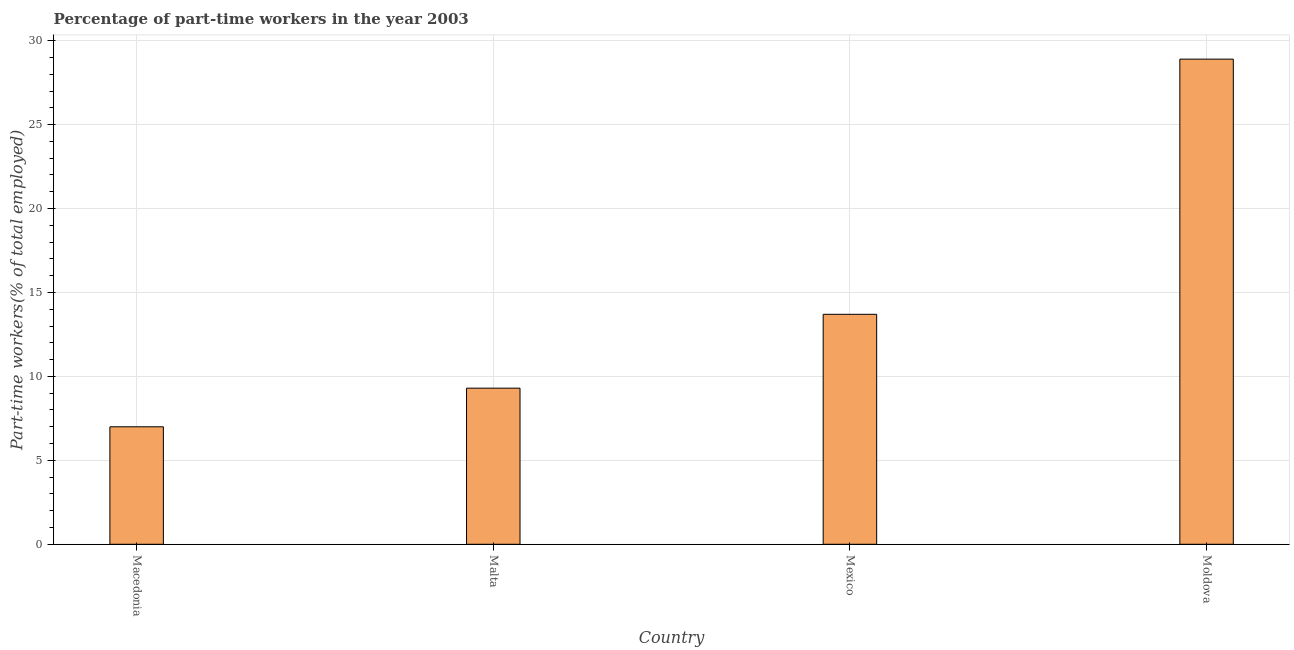Does the graph contain any zero values?
Offer a terse response. No. Does the graph contain grids?
Your answer should be compact. Yes. What is the title of the graph?
Your answer should be compact. Percentage of part-time workers in the year 2003. What is the label or title of the X-axis?
Offer a very short reply. Country. What is the label or title of the Y-axis?
Make the answer very short. Part-time workers(% of total employed). What is the percentage of part-time workers in Mexico?
Provide a short and direct response. 13.7. Across all countries, what is the maximum percentage of part-time workers?
Your response must be concise. 28.9. In which country was the percentage of part-time workers maximum?
Your answer should be compact. Moldova. In which country was the percentage of part-time workers minimum?
Your answer should be compact. Macedonia. What is the sum of the percentage of part-time workers?
Your response must be concise. 58.9. What is the difference between the percentage of part-time workers in Mexico and Moldova?
Provide a succinct answer. -15.2. What is the average percentage of part-time workers per country?
Provide a short and direct response. 14.72. What is the median percentage of part-time workers?
Offer a very short reply. 11.5. In how many countries, is the percentage of part-time workers greater than 26 %?
Give a very brief answer. 1. What is the ratio of the percentage of part-time workers in Malta to that in Moldova?
Your answer should be compact. 0.32. What is the difference between the highest and the second highest percentage of part-time workers?
Give a very brief answer. 15.2. Is the sum of the percentage of part-time workers in Malta and Moldova greater than the maximum percentage of part-time workers across all countries?
Provide a succinct answer. Yes. What is the difference between the highest and the lowest percentage of part-time workers?
Give a very brief answer. 21.9. In how many countries, is the percentage of part-time workers greater than the average percentage of part-time workers taken over all countries?
Provide a succinct answer. 1. How many bars are there?
Offer a very short reply. 4. Are all the bars in the graph horizontal?
Offer a terse response. No. What is the Part-time workers(% of total employed) in Malta?
Ensure brevity in your answer.  9.3. What is the Part-time workers(% of total employed) of Mexico?
Your answer should be very brief. 13.7. What is the Part-time workers(% of total employed) in Moldova?
Offer a terse response. 28.9. What is the difference between the Part-time workers(% of total employed) in Macedonia and Malta?
Your response must be concise. -2.3. What is the difference between the Part-time workers(% of total employed) in Macedonia and Moldova?
Make the answer very short. -21.9. What is the difference between the Part-time workers(% of total employed) in Malta and Moldova?
Make the answer very short. -19.6. What is the difference between the Part-time workers(% of total employed) in Mexico and Moldova?
Your answer should be very brief. -15.2. What is the ratio of the Part-time workers(% of total employed) in Macedonia to that in Malta?
Provide a short and direct response. 0.75. What is the ratio of the Part-time workers(% of total employed) in Macedonia to that in Mexico?
Make the answer very short. 0.51. What is the ratio of the Part-time workers(% of total employed) in Macedonia to that in Moldova?
Your answer should be very brief. 0.24. What is the ratio of the Part-time workers(% of total employed) in Malta to that in Mexico?
Your answer should be very brief. 0.68. What is the ratio of the Part-time workers(% of total employed) in Malta to that in Moldova?
Make the answer very short. 0.32. What is the ratio of the Part-time workers(% of total employed) in Mexico to that in Moldova?
Your response must be concise. 0.47. 